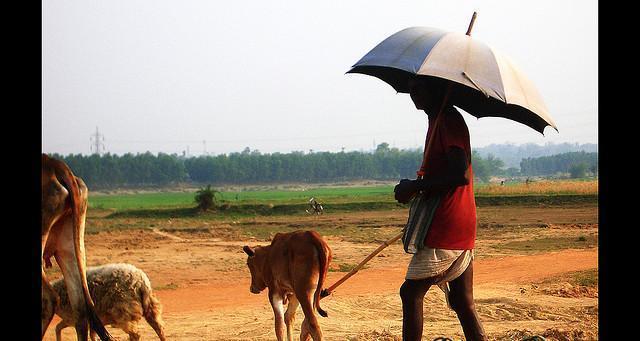How many cows are in the photo?
Give a very brief answer. 2. 